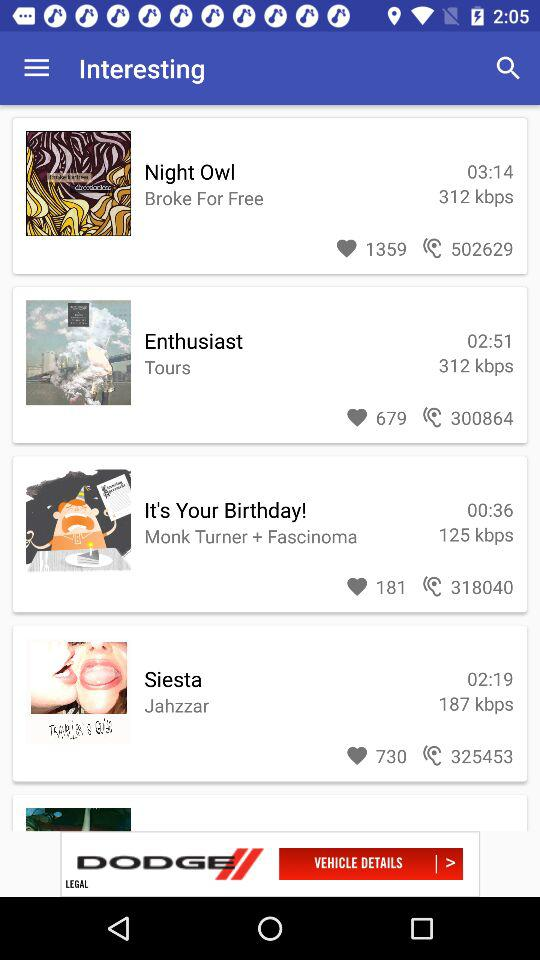What is the speed of siesta? The speed of siesta is 187 kbps. 